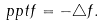Convert formula to latex. <formula><loc_0><loc_0><loc_500><loc_500>\ p p t f = - \triangle f .</formula> 